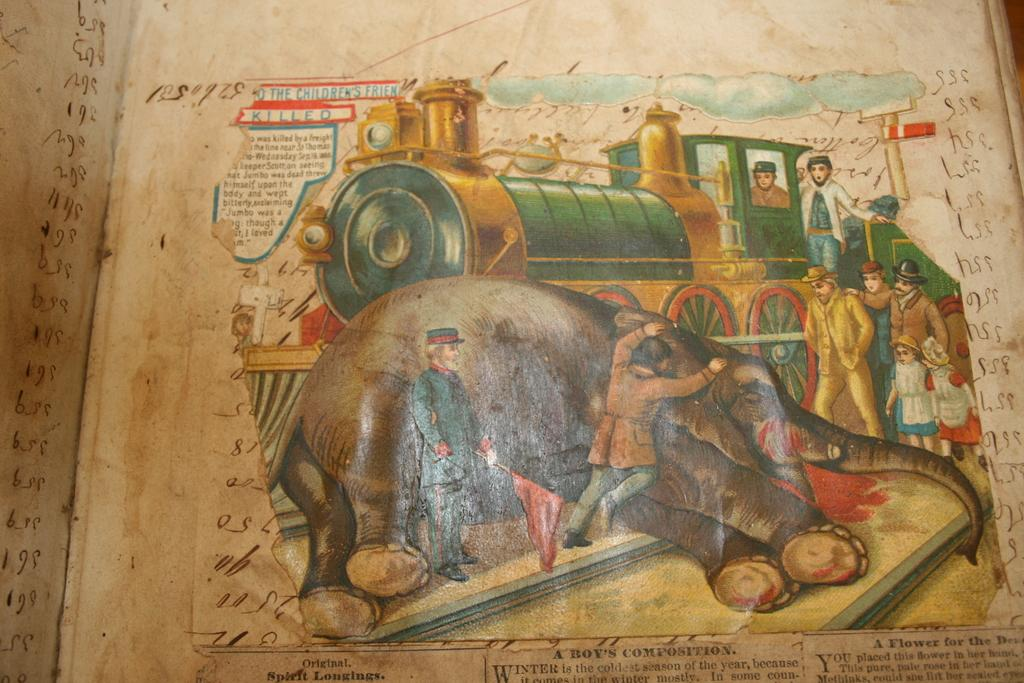<image>
Write a terse but informative summary of the picture. A drawing a train and an elephant with the title A Boy's Composition underneath it. 